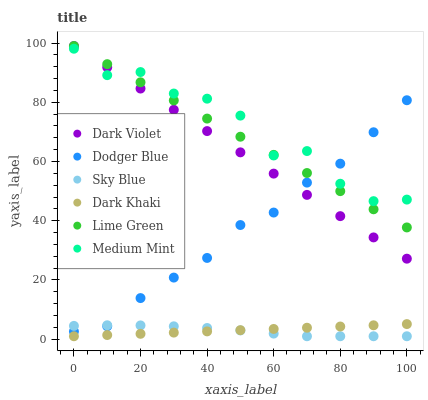Does Sky Blue have the minimum area under the curve?
Answer yes or no. Yes. Does Medium Mint have the maximum area under the curve?
Answer yes or no. Yes. Does Dark Violet have the minimum area under the curve?
Answer yes or no. No. Does Dark Violet have the maximum area under the curve?
Answer yes or no. No. Is Lime Green the smoothest?
Answer yes or no. Yes. Is Medium Mint the roughest?
Answer yes or no. Yes. Is Dark Violet the smoothest?
Answer yes or no. No. Is Dark Violet the roughest?
Answer yes or no. No. Does Dark Khaki have the lowest value?
Answer yes or no. Yes. Does Dark Violet have the lowest value?
Answer yes or no. No. Does Lime Green have the highest value?
Answer yes or no. Yes. Does Dark Khaki have the highest value?
Answer yes or no. No. Is Sky Blue less than Medium Mint?
Answer yes or no. Yes. Is Dark Violet greater than Sky Blue?
Answer yes or no. Yes. Does Medium Mint intersect Dark Violet?
Answer yes or no. Yes. Is Medium Mint less than Dark Violet?
Answer yes or no. No. Is Medium Mint greater than Dark Violet?
Answer yes or no. No. Does Sky Blue intersect Medium Mint?
Answer yes or no. No. 